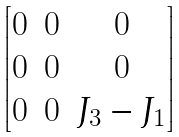<formula> <loc_0><loc_0><loc_500><loc_500>\begin{bmatrix} 0 & 0 & 0 \\ 0 & 0 & 0 \\ 0 & 0 & J _ { 3 } - J _ { 1 } \end{bmatrix}</formula> 